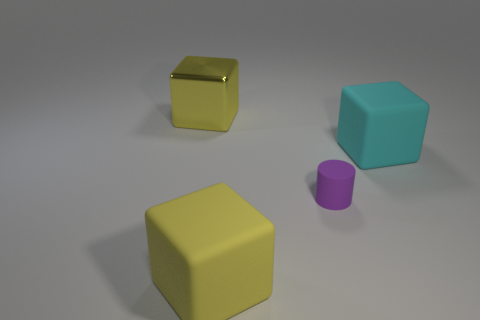Add 4 metallic blocks. How many objects exist? 8 Subtract all large yellow cubes. How many cubes are left? 1 Subtract all cylinders. How many objects are left? 3 Subtract all cyan blocks. How many blocks are left? 2 Subtract all brown objects. Subtract all matte cylinders. How many objects are left? 3 Add 1 blocks. How many blocks are left? 4 Add 2 tiny purple blocks. How many tiny purple blocks exist? 2 Subtract 1 yellow cubes. How many objects are left? 3 Subtract 1 blocks. How many blocks are left? 2 Subtract all red blocks. Subtract all blue cylinders. How many blocks are left? 3 